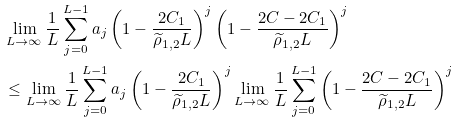Convert formula to latex. <formula><loc_0><loc_0><loc_500><loc_500>& \lim _ { L \to \infty } \frac { 1 } { L } \sum _ { j = 0 } ^ { L - 1 } a _ { j } \left ( 1 - \frac { 2 C _ { 1 } } { \widetilde { \rho } _ { 1 , 2 } L } \right ) ^ { j } \left ( 1 - \frac { 2 C - 2 C _ { 1 } } { \widetilde { \rho } _ { 1 , 2 } L } \right ) ^ { j } \\ & \leq \lim _ { L \to \infty } \frac { 1 } { L } \sum _ { j = 0 } ^ { L - 1 } a _ { j } \left ( 1 - \frac { 2 C _ { 1 } } { \widetilde { \rho } _ { 1 , 2 } L } \right ) ^ { j } \lim _ { L \to \infty } \frac { 1 } { L } \sum _ { j = 0 } ^ { L - 1 } \left ( 1 - \frac { 2 C - 2 C _ { 1 } } { \widetilde { \rho } _ { 1 , 2 } L } \right ) ^ { j }</formula> 